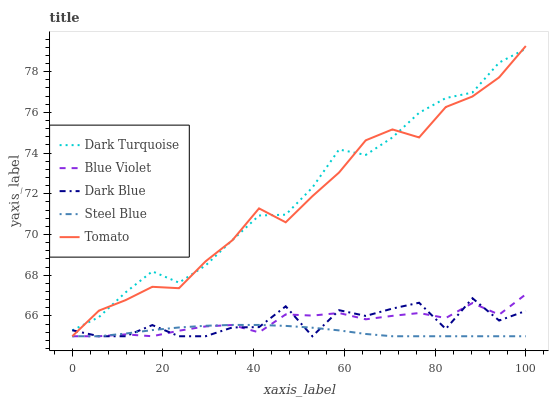Does Steel Blue have the minimum area under the curve?
Answer yes or no. Yes. Does Dark Turquoise have the maximum area under the curve?
Answer yes or no. Yes. Does Dark Turquoise have the minimum area under the curve?
Answer yes or no. No. Does Steel Blue have the maximum area under the curve?
Answer yes or no. No. Is Steel Blue the smoothest?
Answer yes or no. Yes. Is Dark Blue the roughest?
Answer yes or no. Yes. Is Dark Turquoise the smoothest?
Answer yes or no. No. Is Dark Turquoise the roughest?
Answer yes or no. No. Does Dark Turquoise have the lowest value?
Answer yes or no. No. Does Tomato have the highest value?
Answer yes or no. Yes. Does Dark Turquoise have the highest value?
Answer yes or no. No. Is Blue Violet less than Dark Turquoise?
Answer yes or no. Yes. Is Dark Turquoise greater than Steel Blue?
Answer yes or no. Yes. Does Tomato intersect Steel Blue?
Answer yes or no. Yes. Is Tomato less than Steel Blue?
Answer yes or no. No. Is Tomato greater than Steel Blue?
Answer yes or no. No. Does Blue Violet intersect Dark Turquoise?
Answer yes or no. No. 